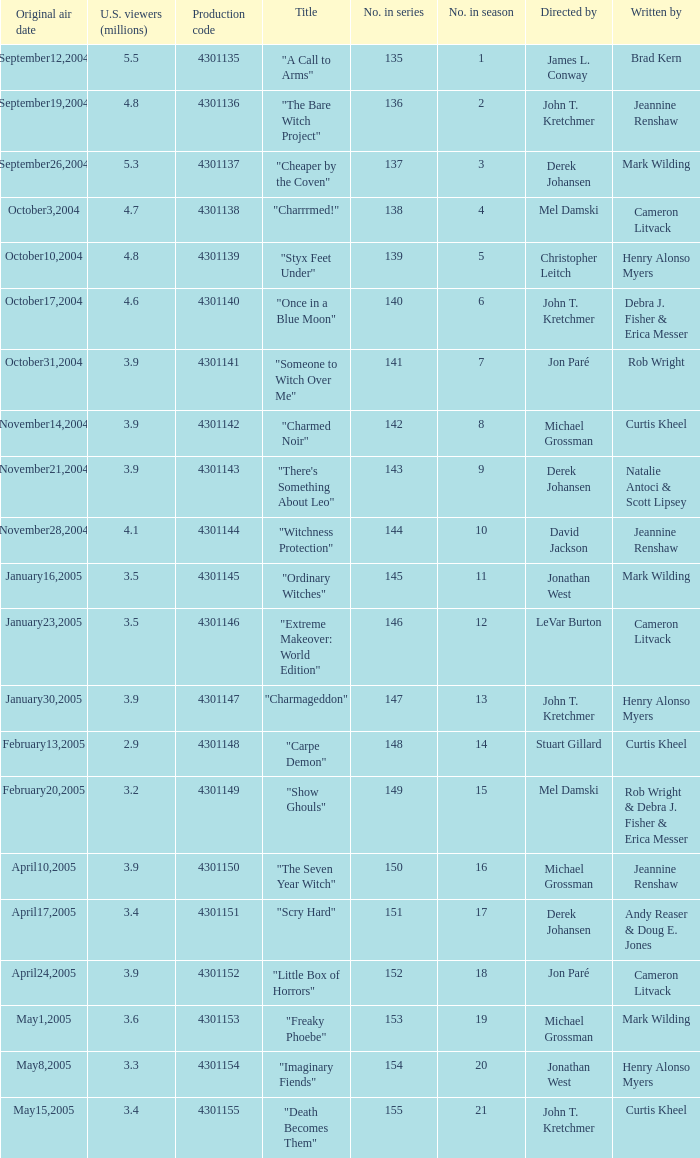In season number 3,  who were the writers? Mark Wilding. 